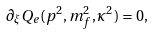<formula> <loc_0><loc_0><loc_500><loc_500>\partial _ { \xi } Q _ { e } ( p ^ { 2 } , m _ { f } ^ { 2 } , \kappa ^ { 2 } ) = 0 ,</formula> 